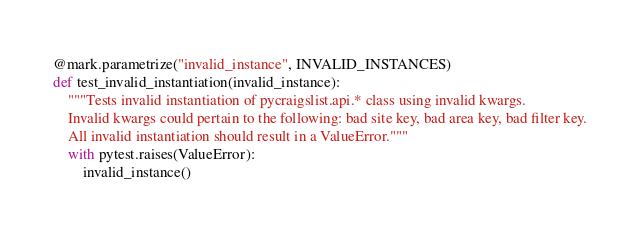Convert code to text. <code><loc_0><loc_0><loc_500><loc_500><_Python_>@mark.parametrize("invalid_instance", INVALID_INSTANCES)
def test_invalid_instantiation(invalid_instance):
    """Tests invalid instantiation of pycraigslist.api.* class using invalid kwargs.
    Invalid kwargs could pertain to the following: bad site key, bad area key, bad filter key.
    All invalid instantiation should result in a ValueError."""
    with pytest.raises(ValueError):
        invalid_instance()
</code> 